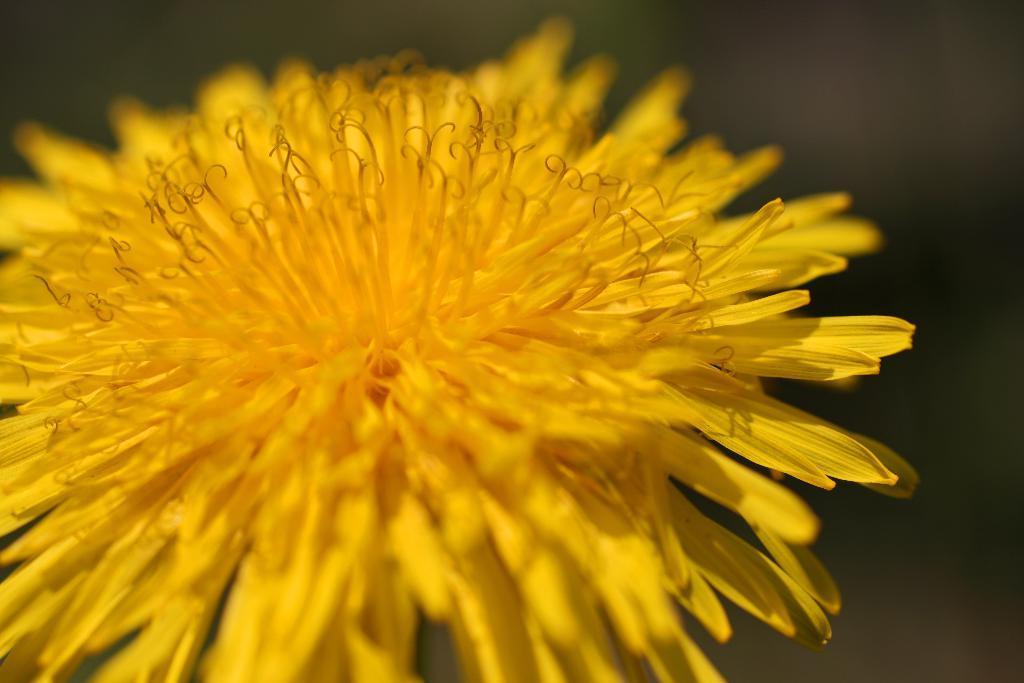Can you describe this image briefly? In this picture we can see yellow color flower. On the top right we can see darkness. 